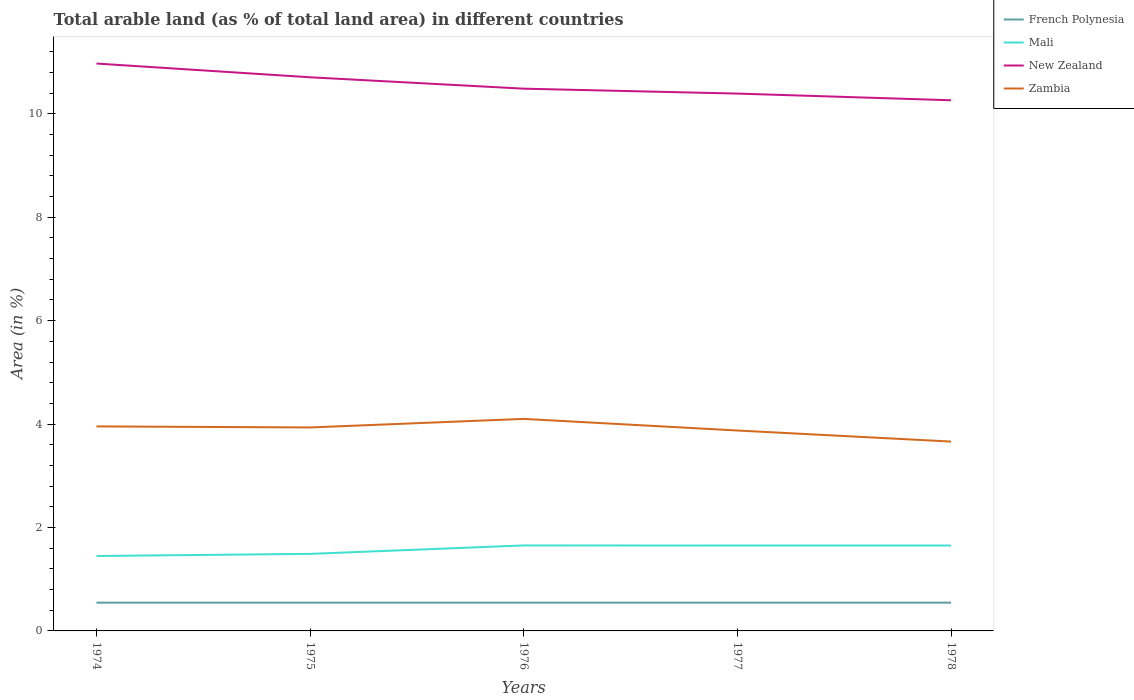Across all years, what is the maximum percentage of arable land in New Zealand?
Your response must be concise. 10.26. In which year was the percentage of arable land in French Polynesia maximum?
Your response must be concise. 1974. What is the difference between the highest and the second highest percentage of arable land in Zambia?
Your response must be concise. 0.44. What is the difference between the highest and the lowest percentage of arable land in New Zealand?
Give a very brief answer. 2. How many years are there in the graph?
Your response must be concise. 5. What is the difference between two consecutive major ticks on the Y-axis?
Your response must be concise. 2. Does the graph contain any zero values?
Your answer should be compact. No. How many legend labels are there?
Give a very brief answer. 4. What is the title of the graph?
Ensure brevity in your answer.  Total arable land (as % of total land area) in different countries. What is the label or title of the X-axis?
Your answer should be compact. Years. What is the label or title of the Y-axis?
Keep it short and to the point. Area (in %). What is the Area (in %) of French Polynesia in 1974?
Give a very brief answer. 0.55. What is the Area (in %) of Mali in 1974?
Your response must be concise. 1.45. What is the Area (in %) in New Zealand in 1974?
Your response must be concise. 10.97. What is the Area (in %) in Zambia in 1974?
Your response must be concise. 3.95. What is the Area (in %) in French Polynesia in 1975?
Ensure brevity in your answer.  0.55. What is the Area (in %) in Mali in 1975?
Provide a succinct answer. 1.49. What is the Area (in %) in New Zealand in 1975?
Provide a short and direct response. 10.71. What is the Area (in %) in Zambia in 1975?
Offer a terse response. 3.93. What is the Area (in %) in French Polynesia in 1976?
Make the answer very short. 0.55. What is the Area (in %) of Mali in 1976?
Offer a very short reply. 1.65. What is the Area (in %) of New Zealand in 1976?
Make the answer very short. 10.49. What is the Area (in %) of Zambia in 1976?
Keep it short and to the point. 4.1. What is the Area (in %) in French Polynesia in 1977?
Your response must be concise. 0.55. What is the Area (in %) in Mali in 1977?
Give a very brief answer. 1.65. What is the Area (in %) of New Zealand in 1977?
Your answer should be very brief. 10.39. What is the Area (in %) of Zambia in 1977?
Your response must be concise. 3.88. What is the Area (in %) in French Polynesia in 1978?
Offer a terse response. 0.55. What is the Area (in %) of Mali in 1978?
Give a very brief answer. 1.65. What is the Area (in %) of New Zealand in 1978?
Your answer should be compact. 10.26. What is the Area (in %) in Zambia in 1978?
Ensure brevity in your answer.  3.66. Across all years, what is the maximum Area (in %) of French Polynesia?
Your answer should be compact. 0.55. Across all years, what is the maximum Area (in %) of Mali?
Provide a short and direct response. 1.65. Across all years, what is the maximum Area (in %) of New Zealand?
Offer a very short reply. 10.97. Across all years, what is the maximum Area (in %) in Zambia?
Provide a short and direct response. 4.1. Across all years, what is the minimum Area (in %) in French Polynesia?
Offer a very short reply. 0.55. Across all years, what is the minimum Area (in %) in Mali?
Give a very brief answer. 1.45. Across all years, what is the minimum Area (in %) of New Zealand?
Keep it short and to the point. 10.26. Across all years, what is the minimum Area (in %) in Zambia?
Provide a succinct answer. 3.66. What is the total Area (in %) in French Polynesia in the graph?
Your answer should be compact. 2.73. What is the total Area (in %) of Mali in the graph?
Give a very brief answer. 7.89. What is the total Area (in %) of New Zealand in the graph?
Ensure brevity in your answer.  52.82. What is the total Area (in %) of Zambia in the graph?
Offer a terse response. 19.53. What is the difference between the Area (in %) of French Polynesia in 1974 and that in 1975?
Ensure brevity in your answer.  0. What is the difference between the Area (in %) in Mali in 1974 and that in 1975?
Your response must be concise. -0.04. What is the difference between the Area (in %) of New Zealand in 1974 and that in 1975?
Keep it short and to the point. 0.27. What is the difference between the Area (in %) in Zambia in 1974 and that in 1975?
Ensure brevity in your answer.  0.02. What is the difference between the Area (in %) of Mali in 1974 and that in 1976?
Your answer should be very brief. -0.2. What is the difference between the Area (in %) of New Zealand in 1974 and that in 1976?
Your answer should be very brief. 0.49. What is the difference between the Area (in %) in Zambia in 1974 and that in 1976?
Keep it short and to the point. -0.15. What is the difference between the Area (in %) in Mali in 1974 and that in 1977?
Offer a terse response. -0.2. What is the difference between the Area (in %) in New Zealand in 1974 and that in 1977?
Give a very brief answer. 0.58. What is the difference between the Area (in %) of Zambia in 1974 and that in 1977?
Ensure brevity in your answer.  0.08. What is the difference between the Area (in %) of Mali in 1974 and that in 1978?
Your answer should be compact. -0.2. What is the difference between the Area (in %) of New Zealand in 1974 and that in 1978?
Offer a terse response. 0.71. What is the difference between the Area (in %) in Zambia in 1974 and that in 1978?
Offer a very short reply. 0.29. What is the difference between the Area (in %) in Mali in 1975 and that in 1976?
Offer a terse response. -0.16. What is the difference between the Area (in %) of New Zealand in 1975 and that in 1976?
Keep it short and to the point. 0.22. What is the difference between the Area (in %) in Zambia in 1975 and that in 1976?
Provide a short and direct response. -0.17. What is the difference between the Area (in %) in French Polynesia in 1975 and that in 1977?
Ensure brevity in your answer.  0. What is the difference between the Area (in %) in Mali in 1975 and that in 1977?
Offer a terse response. -0.16. What is the difference between the Area (in %) in New Zealand in 1975 and that in 1977?
Your answer should be compact. 0.32. What is the difference between the Area (in %) in Zambia in 1975 and that in 1977?
Your answer should be very brief. 0.06. What is the difference between the Area (in %) in Mali in 1975 and that in 1978?
Your answer should be compact. -0.16. What is the difference between the Area (in %) of New Zealand in 1975 and that in 1978?
Your response must be concise. 0.44. What is the difference between the Area (in %) of Zambia in 1975 and that in 1978?
Your answer should be very brief. 0.27. What is the difference between the Area (in %) of Mali in 1976 and that in 1977?
Offer a terse response. 0. What is the difference between the Area (in %) in New Zealand in 1976 and that in 1977?
Offer a terse response. 0.09. What is the difference between the Area (in %) of Zambia in 1976 and that in 1977?
Your answer should be very brief. 0.22. What is the difference between the Area (in %) in Mali in 1976 and that in 1978?
Provide a short and direct response. 0. What is the difference between the Area (in %) in New Zealand in 1976 and that in 1978?
Provide a short and direct response. 0.22. What is the difference between the Area (in %) in Zambia in 1976 and that in 1978?
Your answer should be compact. 0.44. What is the difference between the Area (in %) of French Polynesia in 1977 and that in 1978?
Your answer should be very brief. 0. What is the difference between the Area (in %) in New Zealand in 1977 and that in 1978?
Provide a short and direct response. 0.13. What is the difference between the Area (in %) in Zambia in 1977 and that in 1978?
Your response must be concise. 0.21. What is the difference between the Area (in %) in French Polynesia in 1974 and the Area (in %) in Mali in 1975?
Your response must be concise. -0.94. What is the difference between the Area (in %) in French Polynesia in 1974 and the Area (in %) in New Zealand in 1975?
Provide a succinct answer. -10.16. What is the difference between the Area (in %) of French Polynesia in 1974 and the Area (in %) of Zambia in 1975?
Your answer should be very brief. -3.39. What is the difference between the Area (in %) of Mali in 1974 and the Area (in %) of New Zealand in 1975?
Give a very brief answer. -9.26. What is the difference between the Area (in %) of Mali in 1974 and the Area (in %) of Zambia in 1975?
Provide a succinct answer. -2.49. What is the difference between the Area (in %) of New Zealand in 1974 and the Area (in %) of Zambia in 1975?
Give a very brief answer. 7.04. What is the difference between the Area (in %) of French Polynesia in 1974 and the Area (in %) of Mali in 1976?
Your response must be concise. -1.11. What is the difference between the Area (in %) in French Polynesia in 1974 and the Area (in %) in New Zealand in 1976?
Your answer should be very brief. -9.94. What is the difference between the Area (in %) of French Polynesia in 1974 and the Area (in %) of Zambia in 1976?
Your answer should be compact. -3.55. What is the difference between the Area (in %) of Mali in 1974 and the Area (in %) of New Zealand in 1976?
Your answer should be compact. -9.04. What is the difference between the Area (in %) of Mali in 1974 and the Area (in %) of Zambia in 1976?
Offer a very short reply. -2.65. What is the difference between the Area (in %) in New Zealand in 1974 and the Area (in %) in Zambia in 1976?
Offer a terse response. 6.87. What is the difference between the Area (in %) of French Polynesia in 1974 and the Area (in %) of Mali in 1977?
Make the answer very short. -1.1. What is the difference between the Area (in %) of French Polynesia in 1974 and the Area (in %) of New Zealand in 1977?
Keep it short and to the point. -9.84. What is the difference between the Area (in %) in French Polynesia in 1974 and the Area (in %) in Zambia in 1977?
Your response must be concise. -3.33. What is the difference between the Area (in %) in Mali in 1974 and the Area (in %) in New Zealand in 1977?
Offer a terse response. -8.94. What is the difference between the Area (in %) in Mali in 1974 and the Area (in %) in Zambia in 1977?
Give a very brief answer. -2.43. What is the difference between the Area (in %) in New Zealand in 1974 and the Area (in %) in Zambia in 1977?
Provide a short and direct response. 7.1. What is the difference between the Area (in %) of French Polynesia in 1974 and the Area (in %) of Mali in 1978?
Your response must be concise. -1.1. What is the difference between the Area (in %) of French Polynesia in 1974 and the Area (in %) of New Zealand in 1978?
Give a very brief answer. -9.72. What is the difference between the Area (in %) of French Polynesia in 1974 and the Area (in %) of Zambia in 1978?
Ensure brevity in your answer.  -3.12. What is the difference between the Area (in %) of Mali in 1974 and the Area (in %) of New Zealand in 1978?
Offer a terse response. -8.81. What is the difference between the Area (in %) in Mali in 1974 and the Area (in %) in Zambia in 1978?
Provide a short and direct response. -2.21. What is the difference between the Area (in %) in New Zealand in 1974 and the Area (in %) in Zambia in 1978?
Provide a succinct answer. 7.31. What is the difference between the Area (in %) in French Polynesia in 1975 and the Area (in %) in Mali in 1976?
Keep it short and to the point. -1.11. What is the difference between the Area (in %) of French Polynesia in 1975 and the Area (in %) of New Zealand in 1976?
Provide a succinct answer. -9.94. What is the difference between the Area (in %) in French Polynesia in 1975 and the Area (in %) in Zambia in 1976?
Your answer should be very brief. -3.55. What is the difference between the Area (in %) in Mali in 1975 and the Area (in %) in New Zealand in 1976?
Provide a short and direct response. -9. What is the difference between the Area (in %) of Mali in 1975 and the Area (in %) of Zambia in 1976?
Provide a short and direct response. -2.61. What is the difference between the Area (in %) of New Zealand in 1975 and the Area (in %) of Zambia in 1976?
Provide a short and direct response. 6.61. What is the difference between the Area (in %) in French Polynesia in 1975 and the Area (in %) in Mali in 1977?
Keep it short and to the point. -1.1. What is the difference between the Area (in %) in French Polynesia in 1975 and the Area (in %) in New Zealand in 1977?
Give a very brief answer. -9.84. What is the difference between the Area (in %) in French Polynesia in 1975 and the Area (in %) in Zambia in 1977?
Offer a terse response. -3.33. What is the difference between the Area (in %) of Mali in 1975 and the Area (in %) of New Zealand in 1977?
Provide a succinct answer. -8.9. What is the difference between the Area (in %) in Mali in 1975 and the Area (in %) in Zambia in 1977?
Offer a terse response. -2.39. What is the difference between the Area (in %) in New Zealand in 1975 and the Area (in %) in Zambia in 1977?
Offer a terse response. 6.83. What is the difference between the Area (in %) of French Polynesia in 1975 and the Area (in %) of Mali in 1978?
Provide a succinct answer. -1.1. What is the difference between the Area (in %) in French Polynesia in 1975 and the Area (in %) in New Zealand in 1978?
Ensure brevity in your answer.  -9.72. What is the difference between the Area (in %) of French Polynesia in 1975 and the Area (in %) of Zambia in 1978?
Your answer should be very brief. -3.12. What is the difference between the Area (in %) of Mali in 1975 and the Area (in %) of New Zealand in 1978?
Offer a terse response. -8.77. What is the difference between the Area (in %) in Mali in 1975 and the Area (in %) in Zambia in 1978?
Give a very brief answer. -2.17. What is the difference between the Area (in %) in New Zealand in 1975 and the Area (in %) in Zambia in 1978?
Offer a terse response. 7.04. What is the difference between the Area (in %) in French Polynesia in 1976 and the Area (in %) in Mali in 1977?
Ensure brevity in your answer.  -1.1. What is the difference between the Area (in %) in French Polynesia in 1976 and the Area (in %) in New Zealand in 1977?
Ensure brevity in your answer.  -9.84. What is the difference between the Area (in %) in French Polynesia in 1976 and the Area (in %) in Zambia in 1977?
Provide a succinct answer. -3.33. What is the difference between the Area (in %) of Mali in 1976 and the Area (in %) of New Zealand in 1977?
Provide a succinct answer. -8.74. What is the difference between the Area (in %) of Mali in 1976 and the Area (in %) of Zambia in 1977?
Keep it short and to the point. -2.22. What is the difference between the Area (in %) of New Zealand in 1976 and the Area (in %) of Zambia in 1977?
Your response must be concise. 6.61. What is the difference between the Area (in %) of French Polynesia in 1976 and the Area (in %) of Mali in 1978?
Your response must be concise. -1.1. What is the difference between the Area (in %) in French Polynesia in 1976 and the Area (in %) in New Zealand in 1978?
Provide a succinct answer. -9.72. What is the difference between the Area (in %) in French Polynesia in 1976 and the Area (in %) in Zambia in 1978?
Make the answer very short. -3.12. What is the difference between the Area (in %) in Mali in 1976 and the Area (in %) in New Zealand in 1978?
Offer a very short reply. -8.61. What is the difference between the Area (in %) in Mali in 1976 and the Area (in %) in Zambia in 1978?
Your answer should be very brief. -2.01. What is the difference between the Area (in %) in New Zealand in 1976 and the Area (in %) in Zambia in 1978?
Your answer should be compact. 6.82. What is the difference between the Area (in %) in French Polynesia in 1977 and the Area (in %) in Mali in 1978?
Your answer should be compact. -1.1. What is the difference between the Area (in %) in French Polynesia in 1977 and the Area (in %) in New Zealand in 1978?
Ensure brevity in your answer.  -9.72. What is the difference between the Area (in %) in French Polynesia in 1977 and the Area (in %) in Zambia in 1978?
Give a very brief answer. -3.12. What is the difference between the Area (in %) of Mali in 1977 and the Area (in %) of New Zealand in 1978?
Your response must be concise. -8.61. What is the difference between the Area (in %) of Mali in 1977 and the Area (in %) of Zambia in 1978?
Provide a short and direct response. -2.01. What is the difference between the Area (in %) in New Zealand in 1977 and the Area (in %) in Zambia in 1978?
Your answer should be very brief. 6.73. What is the average Area (in %) of French Polynesia per year?
Offer a very short reply. 0.55. What is the average Area (in %) of Mali per year?
Your answer should be compact. 1.58. What is the average Area (in %) of New Zealand per year?
Ensure brevity in your answer.  10.56. What is the average Area (in %) in Zambia per year?
Provide a short and direct response. 3.91. In the year 1974, what is the difference between the Area (in %) in French Polynesia and Area (in %) in Mali?
Give a very brief answer. -0.9. In the year 1974, what is the difference between the Area (in %) of French Polynesia and Area (in %) of New Zealand?
Offer a very short reply. -10.43. In the year 1974, what is the difference between the Area (in %) in French Polynesia and Area (in %) in Zambia?
Your answer should be compact. -3.41. In the year 1974, what is the difference between the Area (in %) of Mali and Area (in %) of New Zealand?
Your answer should be very brief. -9.52. In the year 1974, what is the difference between the Area (in %) of Mali and Area (in %) of Zambia?
Keep it short and to the point. -2.51. In the year 1974, what is the difference between the Area (in %) of New Zealand and Area (in %) of Zambia?
Your response must be concise. 7.02. In the year 1975, what is the difference between the Area (in %) of French Polynesia and Area (in %) of Mali?
Make the answer very short. -0.94. In the year 1975, what is the difference between the Area (in %) in French Polynesia and Area (in %) in New Zealand?
Provide a short and direct response. -10.16. In the year 1975, what is the difference between the Area (in %) of French Polynesia and Area (in %) of Zambia?
Offer a terse response. -3.39. In the year 1975, what is the difference between the Area (in %) in Mali and Area (in %) in New Zealand?
Provide a short and direct response. -9.22. In the year 1975, what is the difference between the Area (in %) in Mali and Area (in %) in Zambia?
Ensure brevity in your answer.  -2.44. In the year 1975, what is the difference between the Area (in %) of New Zealand and Area (in %) of Zambia?
Make the answer very short. 6.77. In the year 1976, what is the difference between the Area (in %) of French Polynesia and Area (in %) of Mali?
Provide a short and direct response. -1.11. In the year 1976, what is the difference between the Area (in %) of French Polynesia and Area (in %) of New Zealand?
Your response must be concise. -9.94. In the year 1976, what is the difference between the Area (in %) of French Polynesia and Area (in %) of Zambia?
Your response must be concise. -3.55. In the year 1976, what is the difference between the Area (in %) of Mali and Area (in %) of New Zealand?
Make the answer very short. -8.83. In the year 1976, what is the difference between the Area (in %) of Mali and Area (in %) of Zambia?
Offer a very short reply. -2.45. In the year 1976, what is the difference between the Area (in %) in New Zealand and Area (in %) in Zambia?
Make the answer very short. 6.39. In the year 1977, what is the difference between the Area (in %) of French Polynesia and Area (in %) of Mali?
Give a very brief answer. -1.1. In the year 1977, what is the difference between the Area (in %) of French Polynesia and Area (in %) of New Zealand?
Your answer should be compact. -9.84. In the year 1977, what is the difference between the Area (in %) in French Polynesia and Area (in %) in Zambia?
Offer a very short reply. -3.33. In the year 1977, what is the difference between the Area (in %) of Mali and Area (in %) of New Zealand?
Your answer should be very brief. -8.74. In the year 1977, what is the difference between the Area (in %) in Mali and Area (in %) in Zambia?
Your answer should be compact. -2.22. In the year 1977, what is the difference between the Area (in %) of New Zealand and Area (in %) of Zambia?
Offer a very short reply. 6.52. In the year 1978, what is the difference between the Area (in %) in French Polynesia and Area (in %) in Mali?
Keep it short and to the point. -1.1. In the year 1978, what is the difference between the Area (in %) in French Polynesia and Area (in %) in New Zealand?
Your answer should be compact. -9.72. In the year 1978, what is the difference between the Area (in %) in French Polynesia and Area (in %) in Zambia?
Your answer should be compact. -3.12. In the year 1978, what is the difference between the Area (in %) of Mali and Area (in %) of New Zealand?
Keep it short and to the point. -8.61. In the year 1978, what is the difference between the Area (in %) of Mali and Area (in %) of Zambia?
Provide a succinct answer. -2.01. In the year 1978, what is the difference between the Area (in %) of New Zealand and Area (in %) of Zambia?
Your answer should be very brief. 6.6. What is the ratio of the Area (in %) of Mali in 1974 to that in 1975?
Your response must be concise. 0.97. What is the ratio of the Area (in %) in New Zealand in 1974 to that in 1975?
Provide a succinct answer. 1.02. What is the ratio of the Area (in %) in Zambia in 1974 to that in 1975?
Your response must be concise. 1.01. What is the ratio of the Area (in %) in French Polynesia in 1974 to that in 1976?
Give a very brief answer. 1. What is the ratio of the Area (in %) in Mali in 1974 to that in 1976?
Your response must be concise. 0.88. What is the ratio of the Area (in %) of New Zealand in 1974 to that in 1976?
Your answer should be very brief. 1.05. What is the ratio of the Area (in %) in Zambia in 1974 to that in 1976?
Ensure brevity in your answer.  0.96. What is the ratio of the Area (in %) in French Polynesia in 1974 to that in 1977?
Your answer should be very brief. 1. What is the ratio of the Area (in %) in Mali in 1974 to that in 1977?
Ensure brevity in your answer.  0.88. What is the ratio of the Area (in %) of New Zealand in 1974 to that in 1977?
Ensure brevity in your answer.  1.06. What is the ratio of the Area (in %) of Zambia in 1974 to that in 1977?
Ensure brevity in your answer.  1.02. What is the ratio of the Area (in %) in French Polynesia in 1974 to that in 1978?
Provide a succinct answer. 1. What is the ratio of the Area (in %) of Mali in 1974 to that in 1978?
Make the answer very short. 0.88. What is the ratio of the Area (in %) in New Zealand in 1974 to that in 1978?
Offer a terse response. 1.07. What is the ratio of the Area (in %) in Zambia in 1974 to that in 1978?
Keep it short and to the point. 1.08. What is the ratio of the Area (in %) in French Polynesia in 1975 to that in 1976?
Offer a very short reply. 1. What is the ratio of the Area (in %) of Mali in 1975 to that in 1976?
Offer a very short reply. 0.9. What is the ratio of the Area (in %) in Zambia in 1975 to that in 1976?
Ensure brevity in your answer.  0.96. What is the ratio of the Area (in %) of French Polynesia in 1975 to that in 1977?
Your answer should be very brief. 1. What is the ratio of the Area (in %) in Mali in 1975 to that in 1977?
Give a very brief answer. 0.9. What is the ratio of the Area (in %) of New Zealand in 1975 to that in 1977?
Your answer should be very brief. 1.03. What is the ratio of the Area (in %) of Zambia in 1975 to that in 1977?
Make the answer very short. 1.02. What is the ratio of the Area (in %) of Mali in 1975 to that in 1978?
Give a very brief answer. 0.9. What is the ratio of the Area (in %) in New Zealand in 1975 to that in 1978?
Your answer should be very brief. 1.04. What is the ratio of the Area (in %) of Zambia in 1975 to that in 1978?
Offer a terse response. 1.07. What is the ratio of the Area (in %) in French Polynesia in 1976 to that in 1977?
Give a very brief answer. 1. What is the ratio of the Area (in %) in New Zealand in 1976 to that in 1977?
Ensure brevity in your answer.  1.01. What is the ratio of the Area (in %) in Zambia in 1976 to that in 1977?
Provide a short and direct response. 1.06. What is the ratio of the Area (in %) of French Polynesia in 1976 to that in 1978?
Offer a terse response. 1. What is the ratio of the Area (in %) in Mali in 1976 to that in 1978?
Your response must be concise. 1. What is the ratio of the Area (in %) of New Zealand in 1976 to that in 1978?
Your answer should be very brief. 1.02. What is the ratio of the Area (in %) of Zambia in 1976 to that in 1978?
Give a very brief answer. 1.12. What is the ratio of the Area (in %) in New Zealand in 1977 to that in 1978?
Your answer should be very brief. 1.01. What is the ratio of the Area (in %) of Zambia in 1977 to that in 1978?
Provide a succinct answer. 1.06. What is the difference between the highest and the second highest Area (in %) in French Polynesia?
Make the answer very short. 0. What is the difference between the highest and the second highest Area (in %) in Mali?
Make the answer very short. 0. What is the difference between the highest and the second highest Area (in %) in New Zealand?
Make the answer very short. 0.27. What is the difference between the highest and the second highest Area (in %) in Zambia?
Your response must be concise. 0.15. What is the difference between the highest and the lowest Area (in %) of French Polynesia?
Your answer should be very brief. 0. What is the difference between the highest and the lowest Area (in %) in Mali?
Give a very brief answer. 0.2. What is the difference between the highest and the lowest Area (in %) in New Zealand?
Offer a terse response. 0.71. What is the difference between the highest and the lowest Area (in %) of Zambia?
Keep it short and to the point. 0.44. 